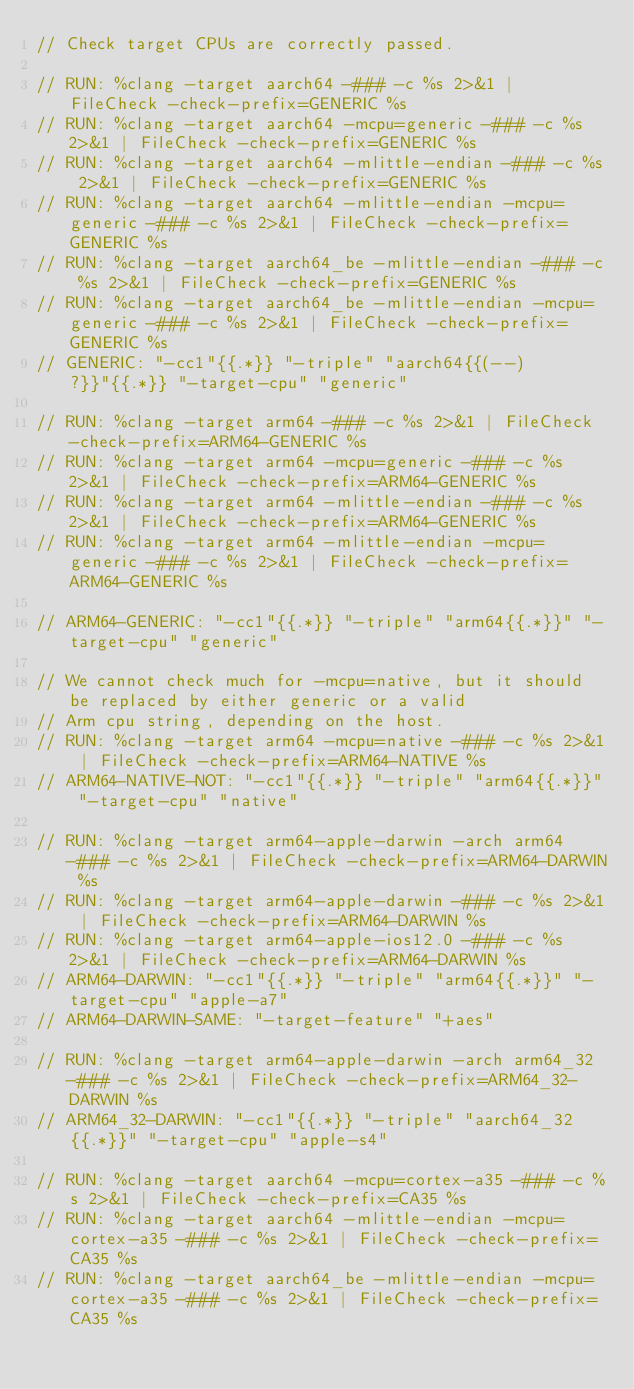<code> <loc_0><loc_0><loc_500><loc_500><_C_>// Check target CPUs are correctly passed.

// RUN: %clang -target aarch64 -### -c %s 2>&1 | FileCheck -check-prefix=GENERIC %s
// RUN: %clang -target aarch64 -mcpu=generic -### -c %s 2>&1 | FileCheck -check-prefix=GENERIC %s
// RUN: %clang -target aarch64 -mlittle-endian -### -c %s 2>&1 | FileCheck -check-prefix=GENERIC %s
// RUN: %clang -target aarch64 -mlittle-endian -mcpu=generic -### -c %s 2>&1 | FileCheck -check-prefix=GENERIC %s
// RUN: %clang -target aarch64_be -mlittle-endian -### -c %s 2>&1 | FileCheck -check-prefix=GENERIC %s
// RUN: %clang -target aarch64_be -mlittle-endian -mcpu=generic -### -c %s 2>&1 | FileCheck -check-prefix=GENERIC %s
// GENERIC: "-cc1"{{.*}} "-triple" "aarch64{{(--)?}}"{{.*}} "-target-cpu" "generic"

// RUN: %clang -target arm64 -### -c %s 2>&1 | FileCheck -check-prefix=ARM64-GENERIC %s
// RUN: %clang -target arm64 -mcpu=generic -### -c %s 2>&1 | FileCheck -check-prefix=ARM64-GENERIC %s
// RUN: %clang -target arm64 -mlittle-endian -### -c %s 2>&1 | FileCheck -check-prefix=ARM64-GENERIC %s
// RUN: %clang -target arm64 -mlittle-endian -mcpu=generic -### -c %s 2>&1 | FileCheck -check-prefix=ARM64-GENERIC %s

// ARM64-GENERIC: "-cc1"{{.*}} "-triple" "arm64{{.*}}" "-target-cpu" "generic"

// We cannot check much for -mcpu=native, but it should be replaced by either generic or a valid
// Arm cpu string, depending on the host.
// RUN: %clang -target arm64 -mcpu=native -### -c %s 2>&1 | FileCheck -check-prefix=ARM64-NATIVE %s
// ARM64-NATIVE-NOT: "-cc1"{{.*}} "-triple" "arm64{{.*}}" "-target-cpu" "native"

// RUN: %clang -target arm64-apple-darwin -arch arm64 -### -c %s 2>&1 | FileCheck -check-prefix=ARM64-DARWIN %s
// RUN: %clang -target arm64-apple-darwin -### -c %s 2>&1 | FileCheck -check-prefix=ARM64-DARWIN %s
// RUN: %clang -target arm64-apple-ios12.0 -### -c %s 2>&1 | FileCheck -check-prefix=ARM64-DARWIN %s
// ARM64-DARWIN: "-cc1"{{.*}} "-triple" "arm64{{.*}}" "-target-cpu" "apple-a7"
// ARM64-DARWIN-SAME: "-target-feature" "+aes"

// RUN: %clang -target arm64-apple-darwin -arch arm64_32 -### -c %s 2>&1 | FileCheck -check-prefix=ARM64_32-DARWIN %s
// ARM64_32-DARWIN: "-cc1"{{.*}} "-triple" "aarch64_32{{.*}}" "-target-cpu" "apple-s4"

// RUN: %clang -target aarch64 -mcpu=cortex-a35 -### -c %s 2>&1 | FileCheck -check-prefix=CA35 %s
// RUN: %clang -target aarch64 -mlittle-endian -mcpu=cortex-a35 -### -c %s 2>&1 | FileCheck -check-prefix=CA35 %s
// RUN: %clang -target aarch64_be -mlittle-endian -mcpu=cortex-a35 -### -c %s 2>&1 | FileCheck -check-prefix=CA35 %s</code> 